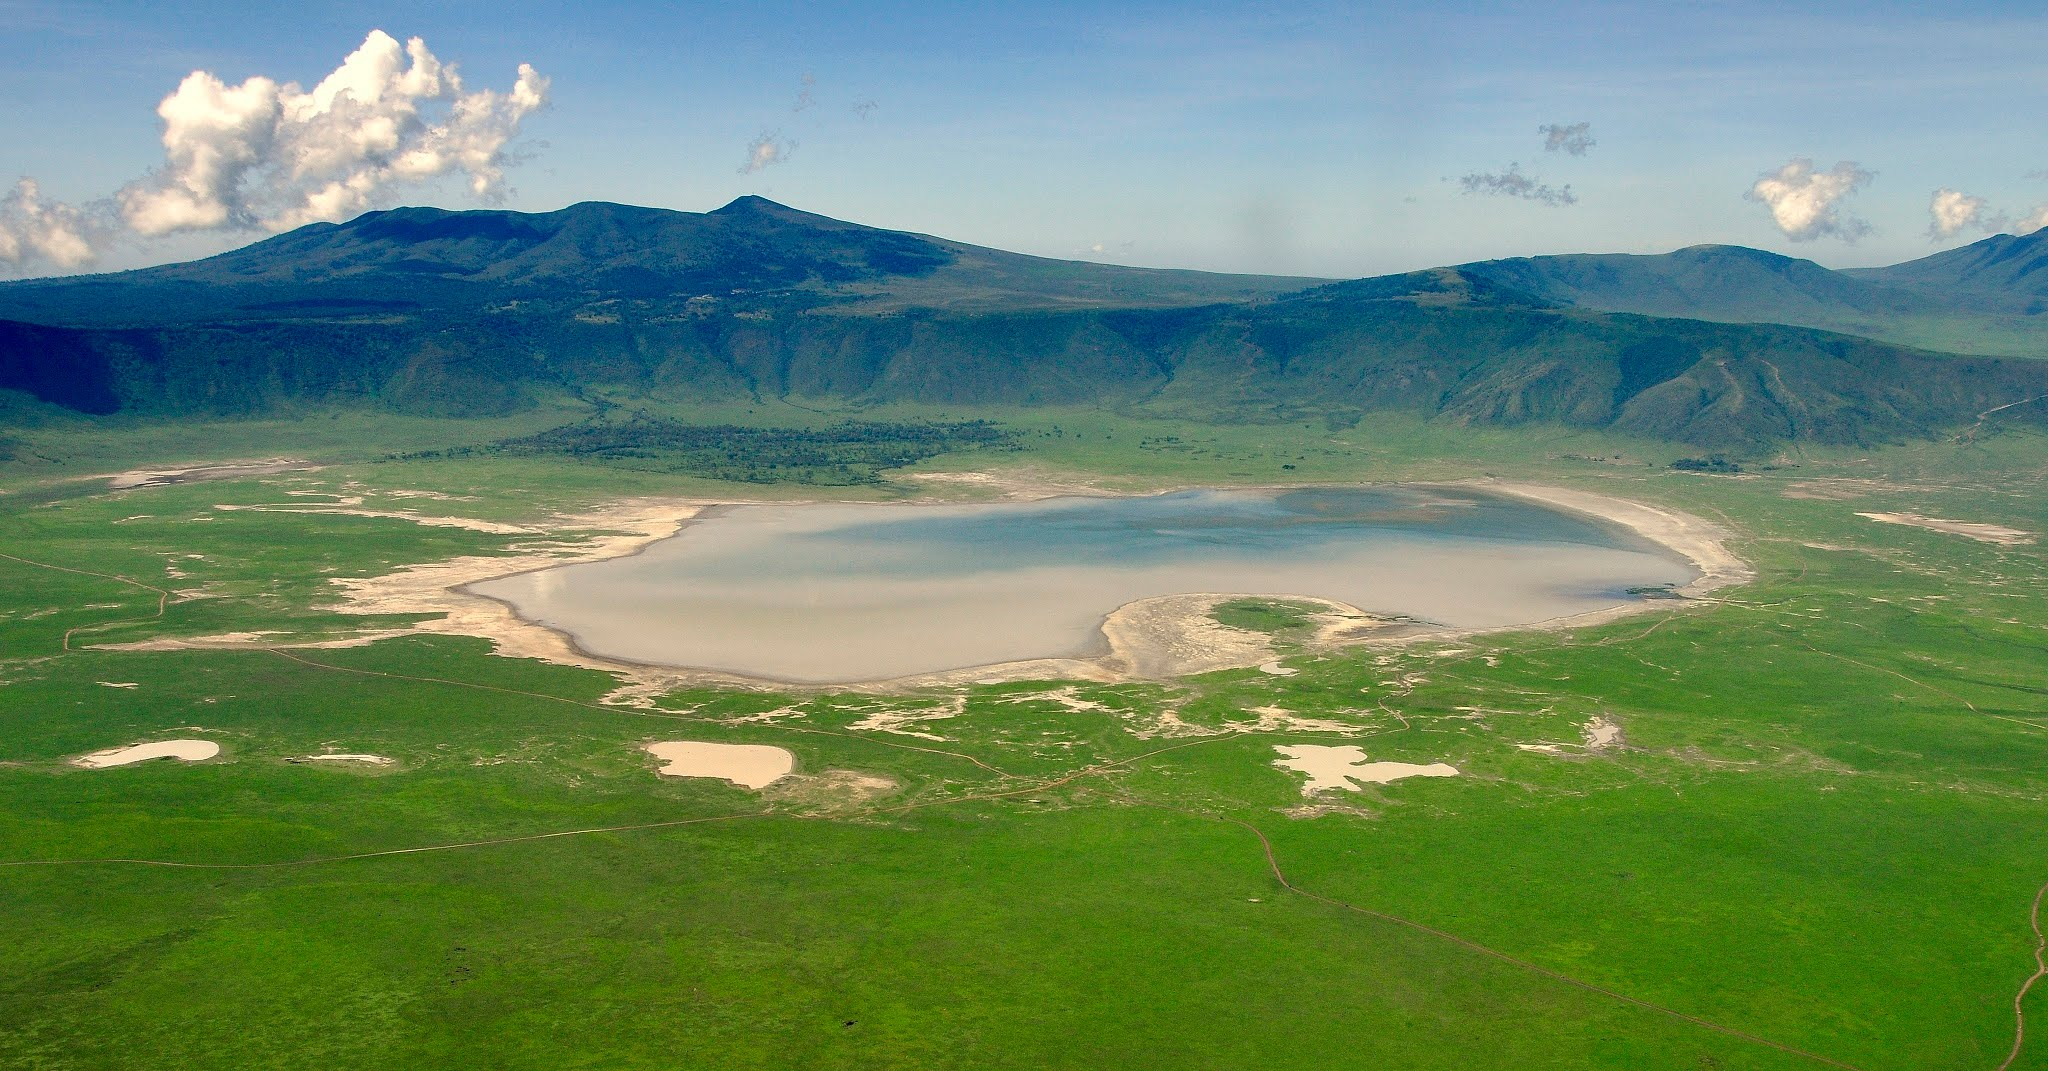Describe an ideal day for a photographer in the Ngorongoro Crater. An ideal day for a photographer in the Ngorongoro Crater would start early, around dawn, to capture the subtle morning light and the dew-clad landscape. As the sun rises, casting a golden hue over the plains, the photographer would focus on the dynamic scenes of wildlife: perhaps a pride of lions quietly stalking their prey, or a herd of elephants trudging to the lake. Mid-morning would be perfect for wide-angle shots that encapsulate the crater's vastness, set against the dramatic backdrop of encircling cliffs. As the day progresses, the photographer could explore the lush forest areas, documenting the vibrant bird life and playful primates. Late afternoon, with the soft, diffused light, would be ideal for portraits of Maasai herders and their cattle against the stunning landscape. As dusk approaches, the crater transforms once again, offering opportunities to capture the ethereal beauty of the sunset reflecting off the lake. Finally, with a tripod set up, the photographer might capture the night sky, using the crater's unique setting to frame the celestial display. 